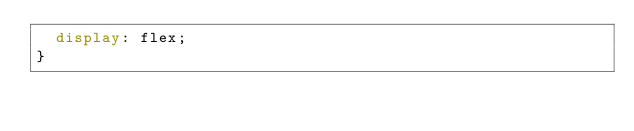Convert code to text. <code><loc_0><loc_0><loc_500><loc_500><_CSS_>  display: flex;
}
</code> 